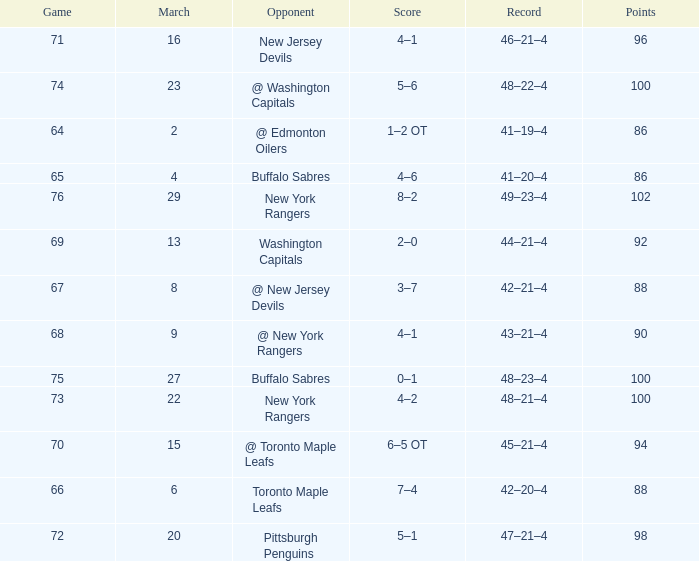Which Opponent has a Record of 45–21–4? @ Toronto Maple Leafs. 